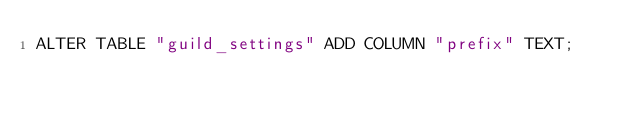Convert code to text. <code><loc_0><loc_0><loc_500><loc_500><_SQL_>ALTER TABLE "guild_settings" ADD COLUMN "prefix" TEXT;
</code> 